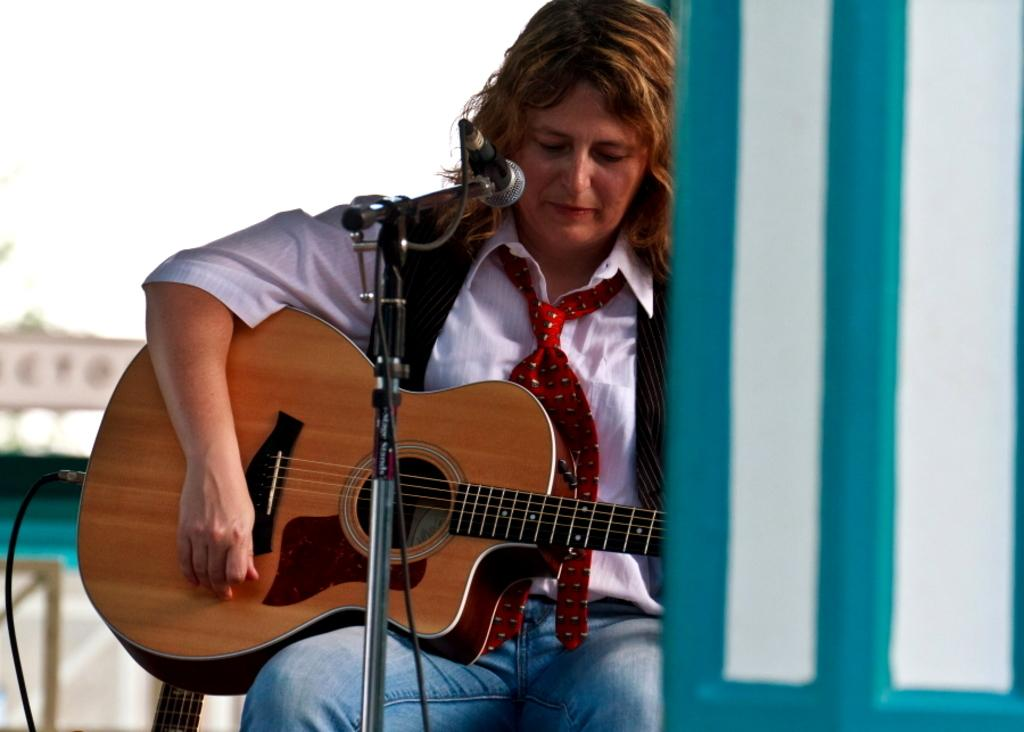Who or what is the main subject in the image? There is a person in the image. What is the person doing in the image? The person is sitting on a chair and playing a guitar. What other object can be seen in the image related to the person's activity? There is a microphone (mike) in the image. What color is the vein visible in the person's arm in the image? There is no visible vein in the person's arm in the image. In which direction is the person facing in the image? The image does not provide enough information to determine the person's exact direction, but we can see that they are facing the microphone. 